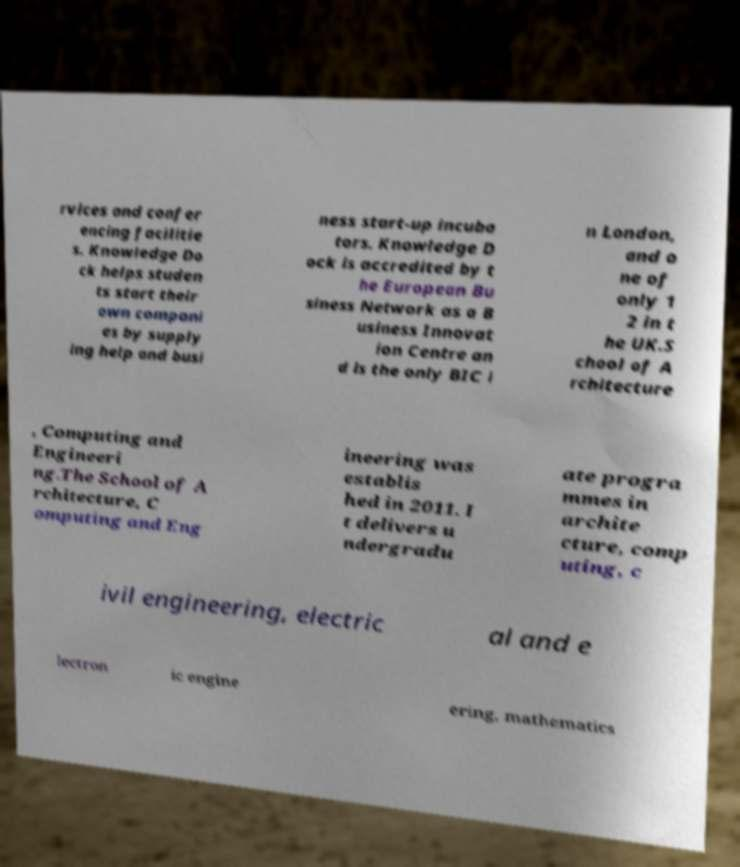I need the written content from this picture converted into text. Can you do that? rvices and confer encing facilitie s. Knowledge Do ck helps studen ts start their own compani es by supply ing help and busi ness start-up incuba tors. Knowledge D ock is accredited by t he European Bu siness Network as a B usiness Innovat ion Centre an d is the only BIC i n London, and o ne of only 1 2 in t he UK.S chool of A rchitecture , Computing and Engineeri ng.The School of A rchitecture, C omputing and Eng ineering was establis hed in 2011. I t delivers u ndergradu ate progra mmes in archite cture, comp uting, c ivil engineering, electric al and e lectron ic engine ering, mathematics 